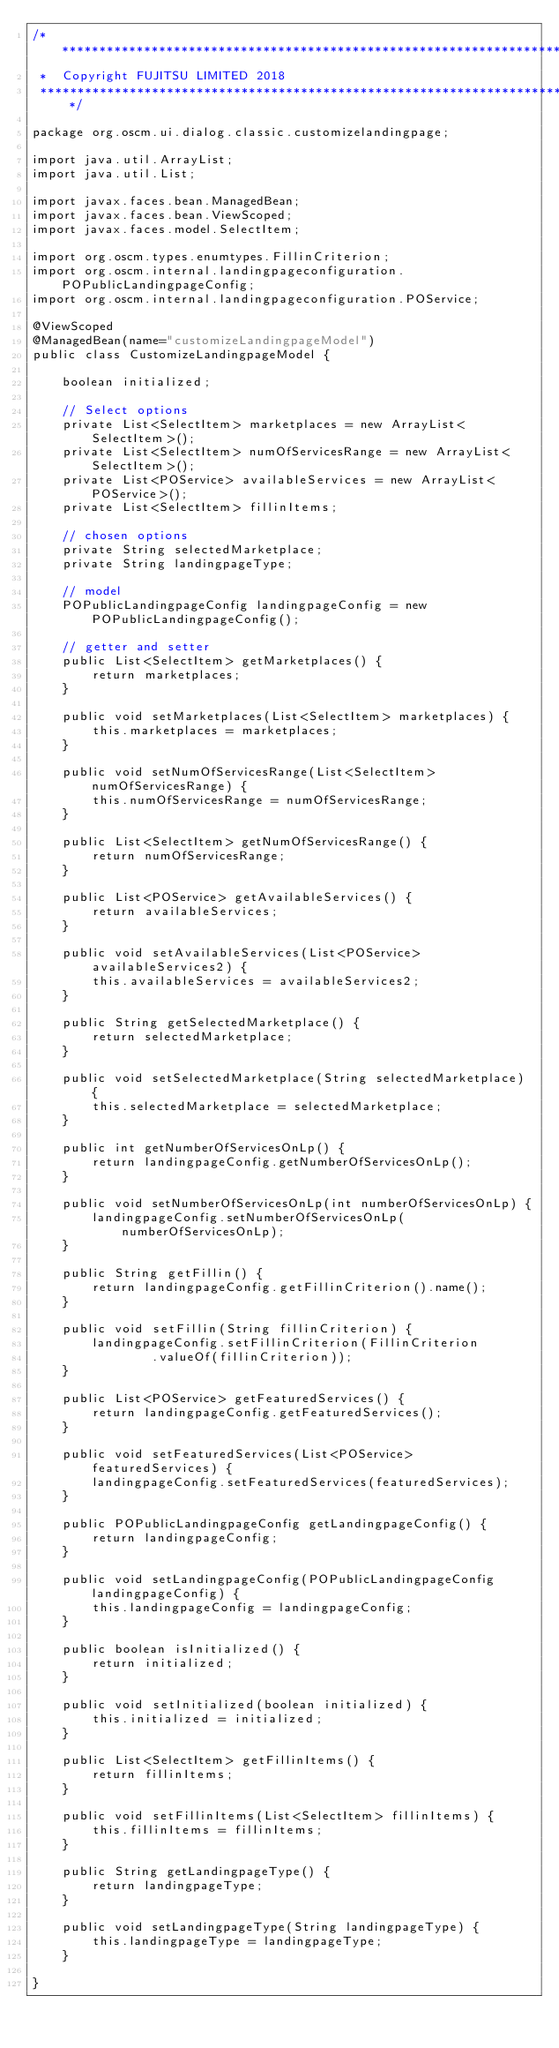Convert code to text. <code><loc_0><loc_0><loc_500><loc_500><_Java_>/*******************************************************************************
 *  Copyright FUJITSU LIMITED 2018
 *******************************************************************************/

package org.oscm.ui.dialog.classic.customizelandingpage;

import java.util.ArrayList;
import java.util.List;

import javax.faces.bean.ManagedBean;
import javax.faces.bean.ViewScoped;
import javax.faces.model.SelectItem;

import org.oscm.types.enumtypes.FillinCriterion;
import org.oscm.internal.landingpageconfiguration.POPublicLandingpageConfig;
import org.oscm.internal.landingpageconfiguration.POService;

@ViewScoped
@ManagedBean(name="customizeLandingpageModel")
public class CustomizeLandingpageModel {

    boolean initialized;

    // Select options
    private List<SelectItem> marketplaces = new ArrayList<SelectItem>();
    private List<SelectItem> numOfServicesRange = new ArrayList<SelectItem>();
    private List<POService> availableServices = new ArrayList<POService>();
    private List<SelectItem> fillinItems;

    // chosen options
    private String selectedMarketplace;
    private String landingpageType;

    // model
    POPublicLandingpageConfig landingpageConfig = new POPublicLandingpageConfig();

    // getter and setter
    public List<SelectItem> getMarketplaces() {
        return marketplaces;
    }

    public void setMarketplaces(List<SelectItem> marketplaces) {
        this.marketplaces = marketplaces;
    }

    public void setNumOfServicesRange(List<SelectItem> numOfServicesRange) {
        this.numOfServicesRange = numOfServicesRange;
    }

    public List<SelectItem> getNumOfServicesRange() {
        return numOfServicesRange;
    }

    public List<POService> getAvailableServices() {
        return availableServices;
    }

    public void setAvailableServices(List<POService> availableServices2) {
        this.availableServices = availableServices2;
    }

    public String getSelectedMarketplace() {
        return selectedMarketplace;
    }

    public void setSelectedMarketplace(String selectedMarketplace) {
        this.selectedMarketplace = selectedMarketplace;
    }

    public int getNumberOfServicesOnLp() {
        return landingpageConfig.getNumberOfServicesOnLp();
    }

    public void setNumberOfServicesOnLp(int numberOfServicesOnLp) {
        landingpageConfig.setNumberOfServicesOnLp(numberOfServicesOnLp);
    }

    public String getFillin() {
        return landingpageConfig.getFillinCriterion().name();
    }

    public void setFillin(String fillinCriterion) {
        landingpageConfig.setFillinCriterion(FillinCriterion
                .valueOf(fillinCriterion));
    }

    public List<POService> getFeaturedServices() {
        return landingpageConfig.getFeaturedServices();
    }

    public void setFeaturedServices(List<POService> featuredServices) {
        landingpageConfig.setFeaturedServices(featuredServices);
    }

    public POPublicLandingpageConfig getLandingpageConfig() {
        return landingpageConfig;
    }

    public void setLandingpageConfig(POPublicLandingpageConfig landingpageConfig) {
        this.landingpageConfig = landingpageConfig;
    }

    public boolean isInitialized() {
        return initialized;
    }

    public void setInitialized(boolean initialized) {
        this.initialized = initialized;
    }

    public List<SelectItem> getFillinItems() {
        return fillinItems;
    }

    public void setFillinItems(List<SelectItem> fillinItems) {
        this.fillinItems = fillinItems;
    }

    public String getLandingpageType() {
        return landingpageType;
    }

    public void setLandingpageType(String landingpageType) {
        this.landingpageType = landingpageType;
    }

}
</code> 